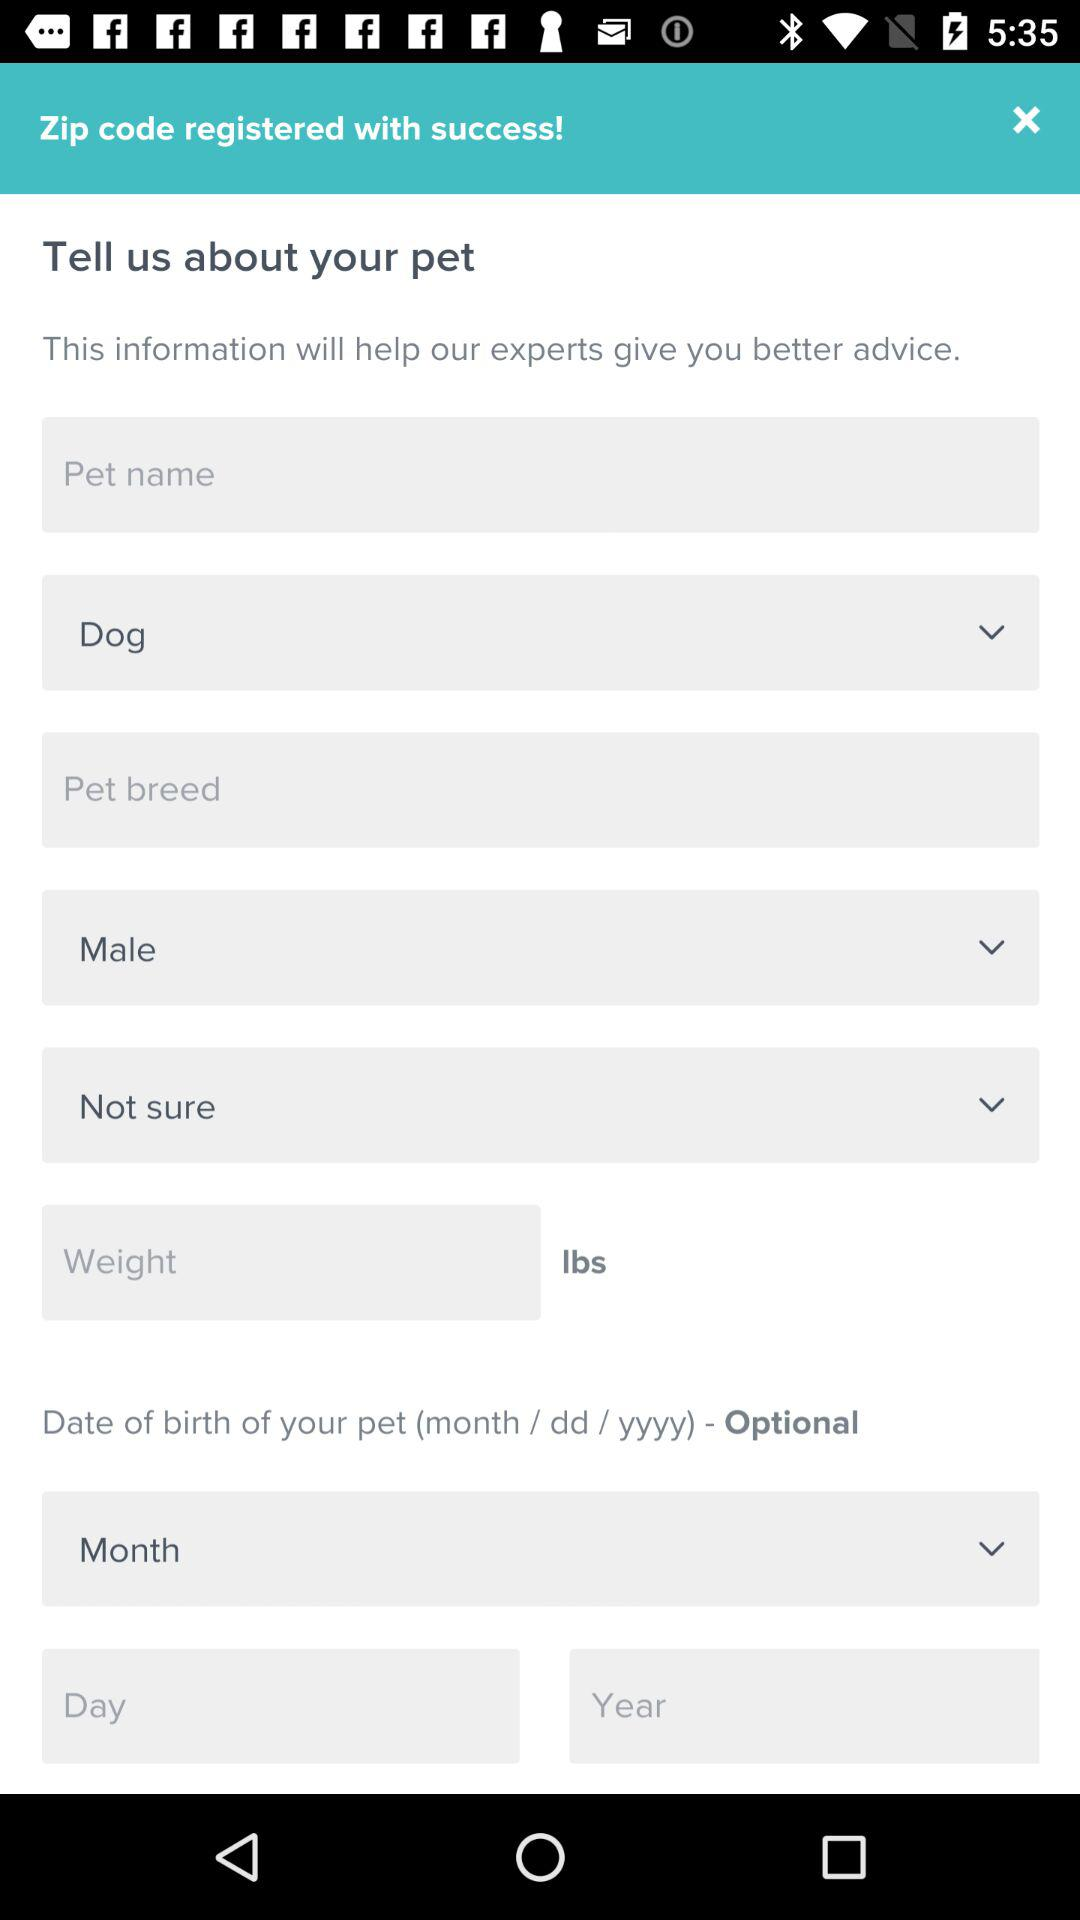Which gender is selected? The selected gender is male. 